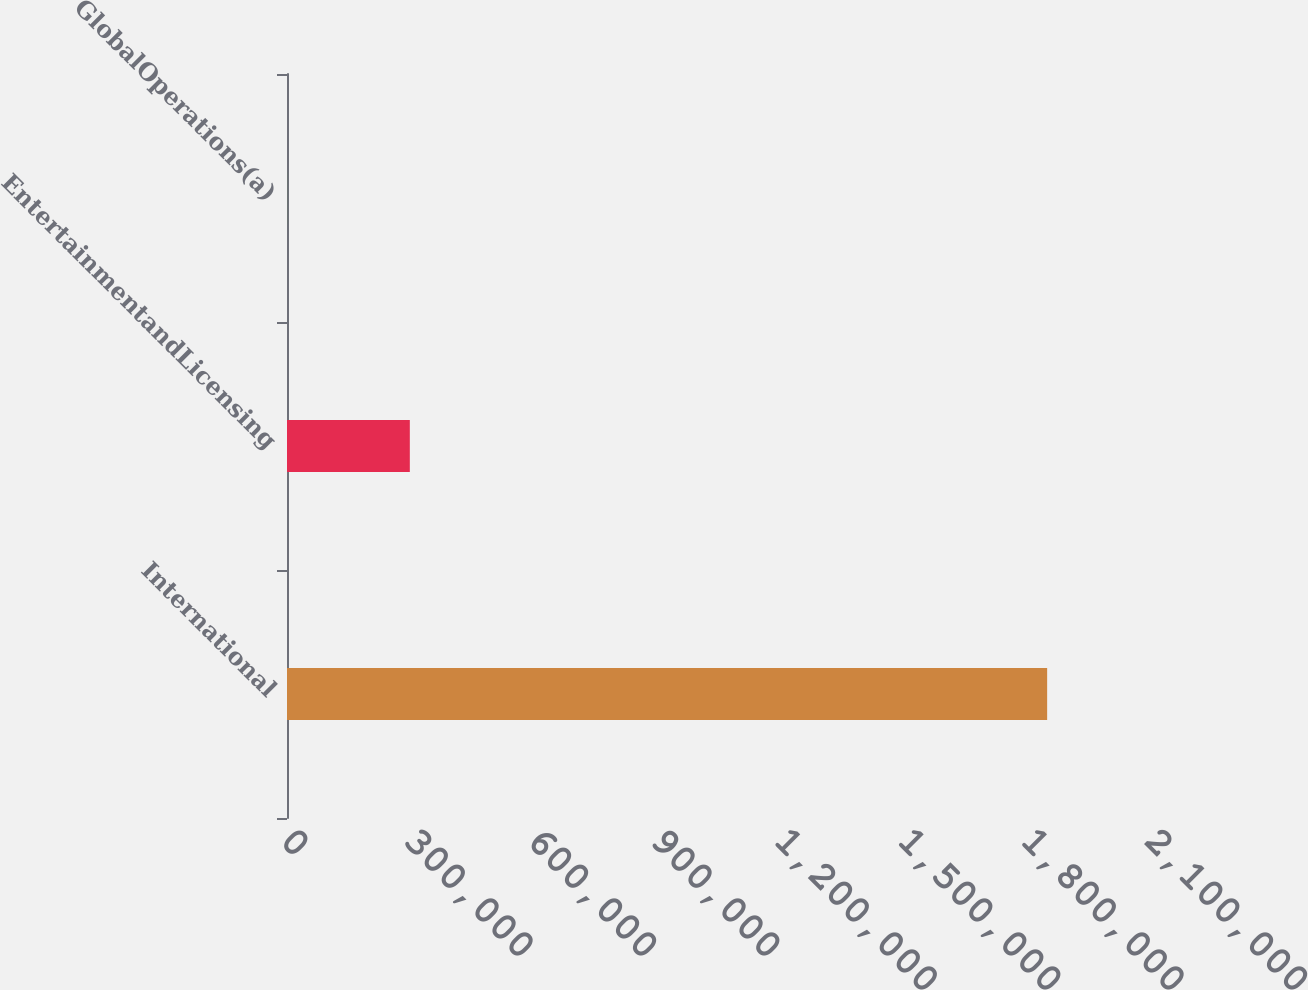<chart> <loc_0><loc_0><loc_500><loc_500><bar_chart><fcel>International<fcel>EntertainmentandLicensing<fcel>GlobalOperations(a)<nl><fcel>1.84758e+06<fcel>298540<fcel>109<nl></chart> 